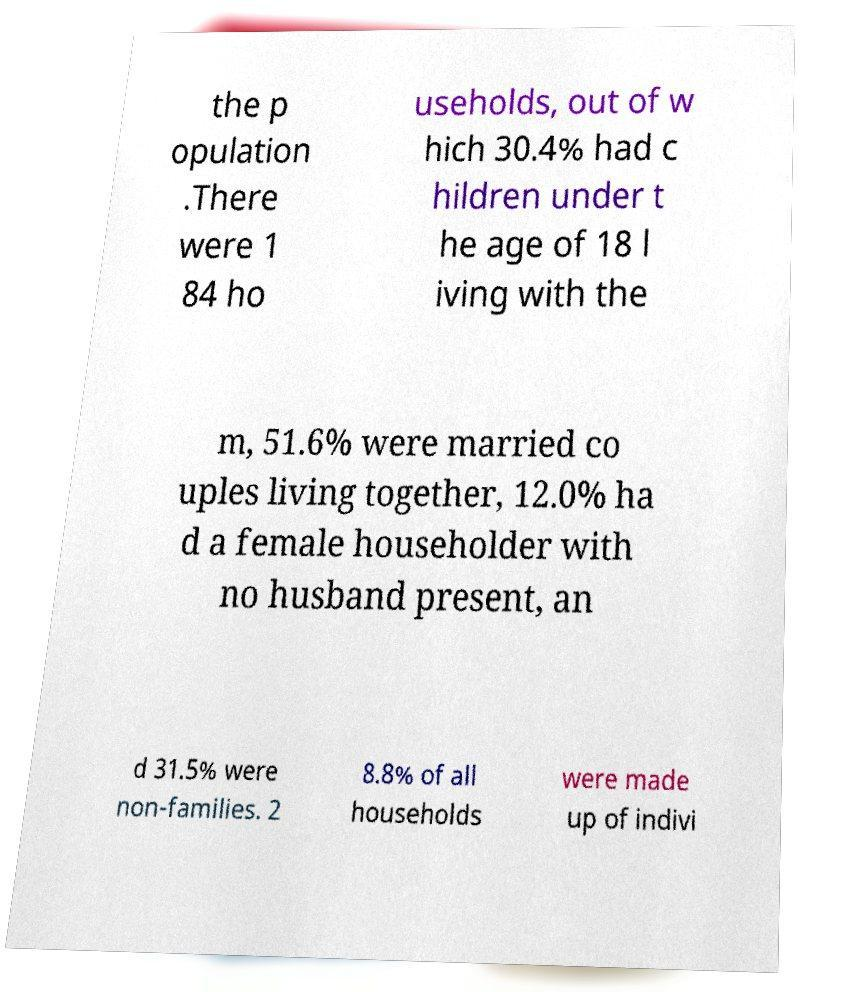What messages or text are displayed in this image? I need them in a readable, typed format. the p opulation .There were 1 84 ho useholds, out of w hich 30.4% had c hildren under t he age of 18 l iving with the m, 51.6% were married co uples living together, 12.0% ha d a female householder with no husband present, an d 31.5% were non-families. 2 8.8% of all households were made up of indivi 